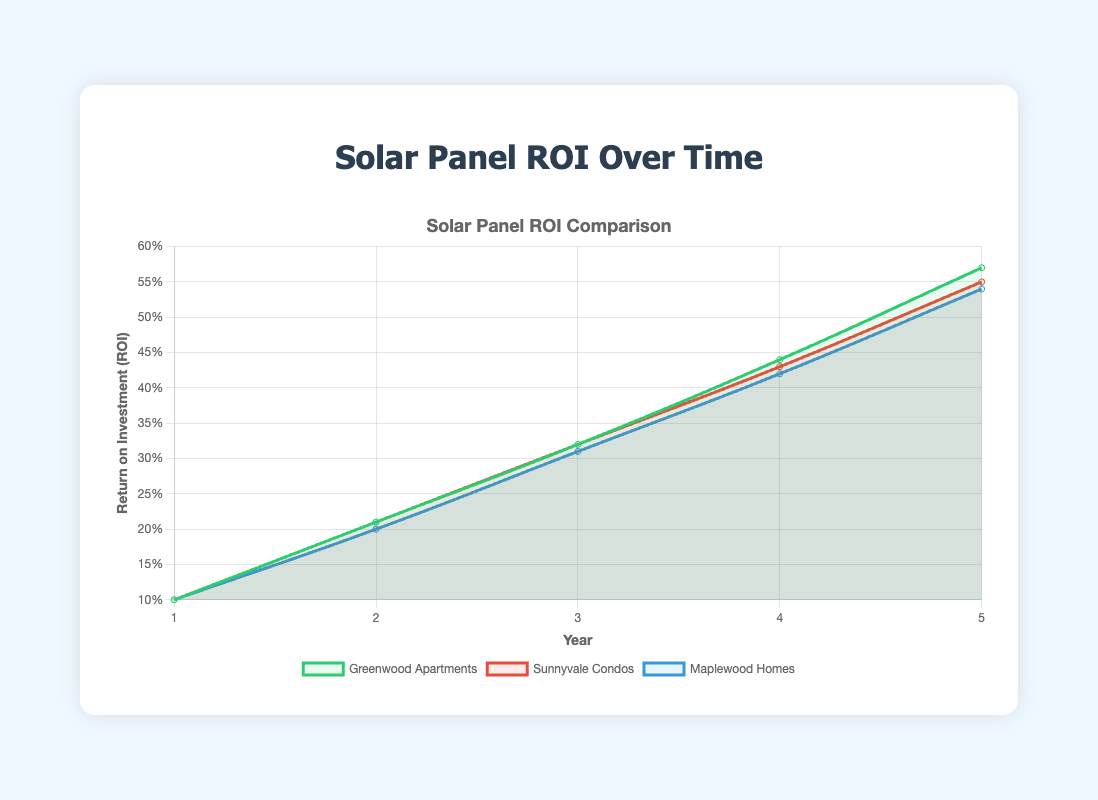What's the ROI for Greenwood Apartments after 3 years? Locate the point on the Greenwood Apartments line at Year 3, which is at 0.32 ROI.
Answer: 0.32 Which property shows the highest ROI after 5 years? Compare the end points of each property line at Year 5. Greenwood Apartments has the highest ROI at 0.57.
Answer: Greenwood Apartments What is the average ROI of Maplewood Homes over the 5-year period? Sum the ROI values of Maplewood Homes for 5 years (0.10 + 0.20 + 0.31 + 0.42 + 0.54) and divide by 5: (1.57 / 5) = 0.314.
Answer: 0.314 By how much does the ROI for Sunnyvale Condos increase from Year 2 to Year 3? Subtract the ROI at Year 2 from the ROI at Year 3 for Sunnyvale Condos: 0.32 - 0.21 = 0.11.
Answer: 0.11 Which property sees the slowest increase in ROI from Year 1 to Year 2? Compare the increase in ROI for each property from Year 1 to Year 2:
- Greenwood Apartments: 0.21 - 0.10 = 0.11
- Sunnyvale Condos: 0.21 - 0.10 = 0.11
- Maplewood Homes: 0.20 - 0.10 = 0.10
Maplewood Homes has the smallest increase.
Answer: Maplewood Homes What is the combined ROI of all properties after 4 years? Sum the ROI values of the three properties at Year 4:
- Greenwood Apartments: 0.44
- Sunnyvale Condos: 0.43
- Maplewood Homes: 0.42
Total: 0.44 + 0.43 + 0.42 = 1.29.
Answer: 1.29 Which property reaches an ROI of over 0.50 the earliest, and in what year? Check when each property crosses 0.50:
- Greenwood Apartments: Year 5 (0.57)
- Sunnyvale Condos: Does not cross until Year 5 (0.55)
- Maplewood Homes: Does not cross until Year 5 (0.54)
Greenwood Apartments reaches it first in Year 5.
Answer: Greenwood Apartments, Year 5 Does the ROI for any property remain constant over any period? Check the slopes of each property line. No segment shows a flat line, indicating a constant ROI.
Answer: No 